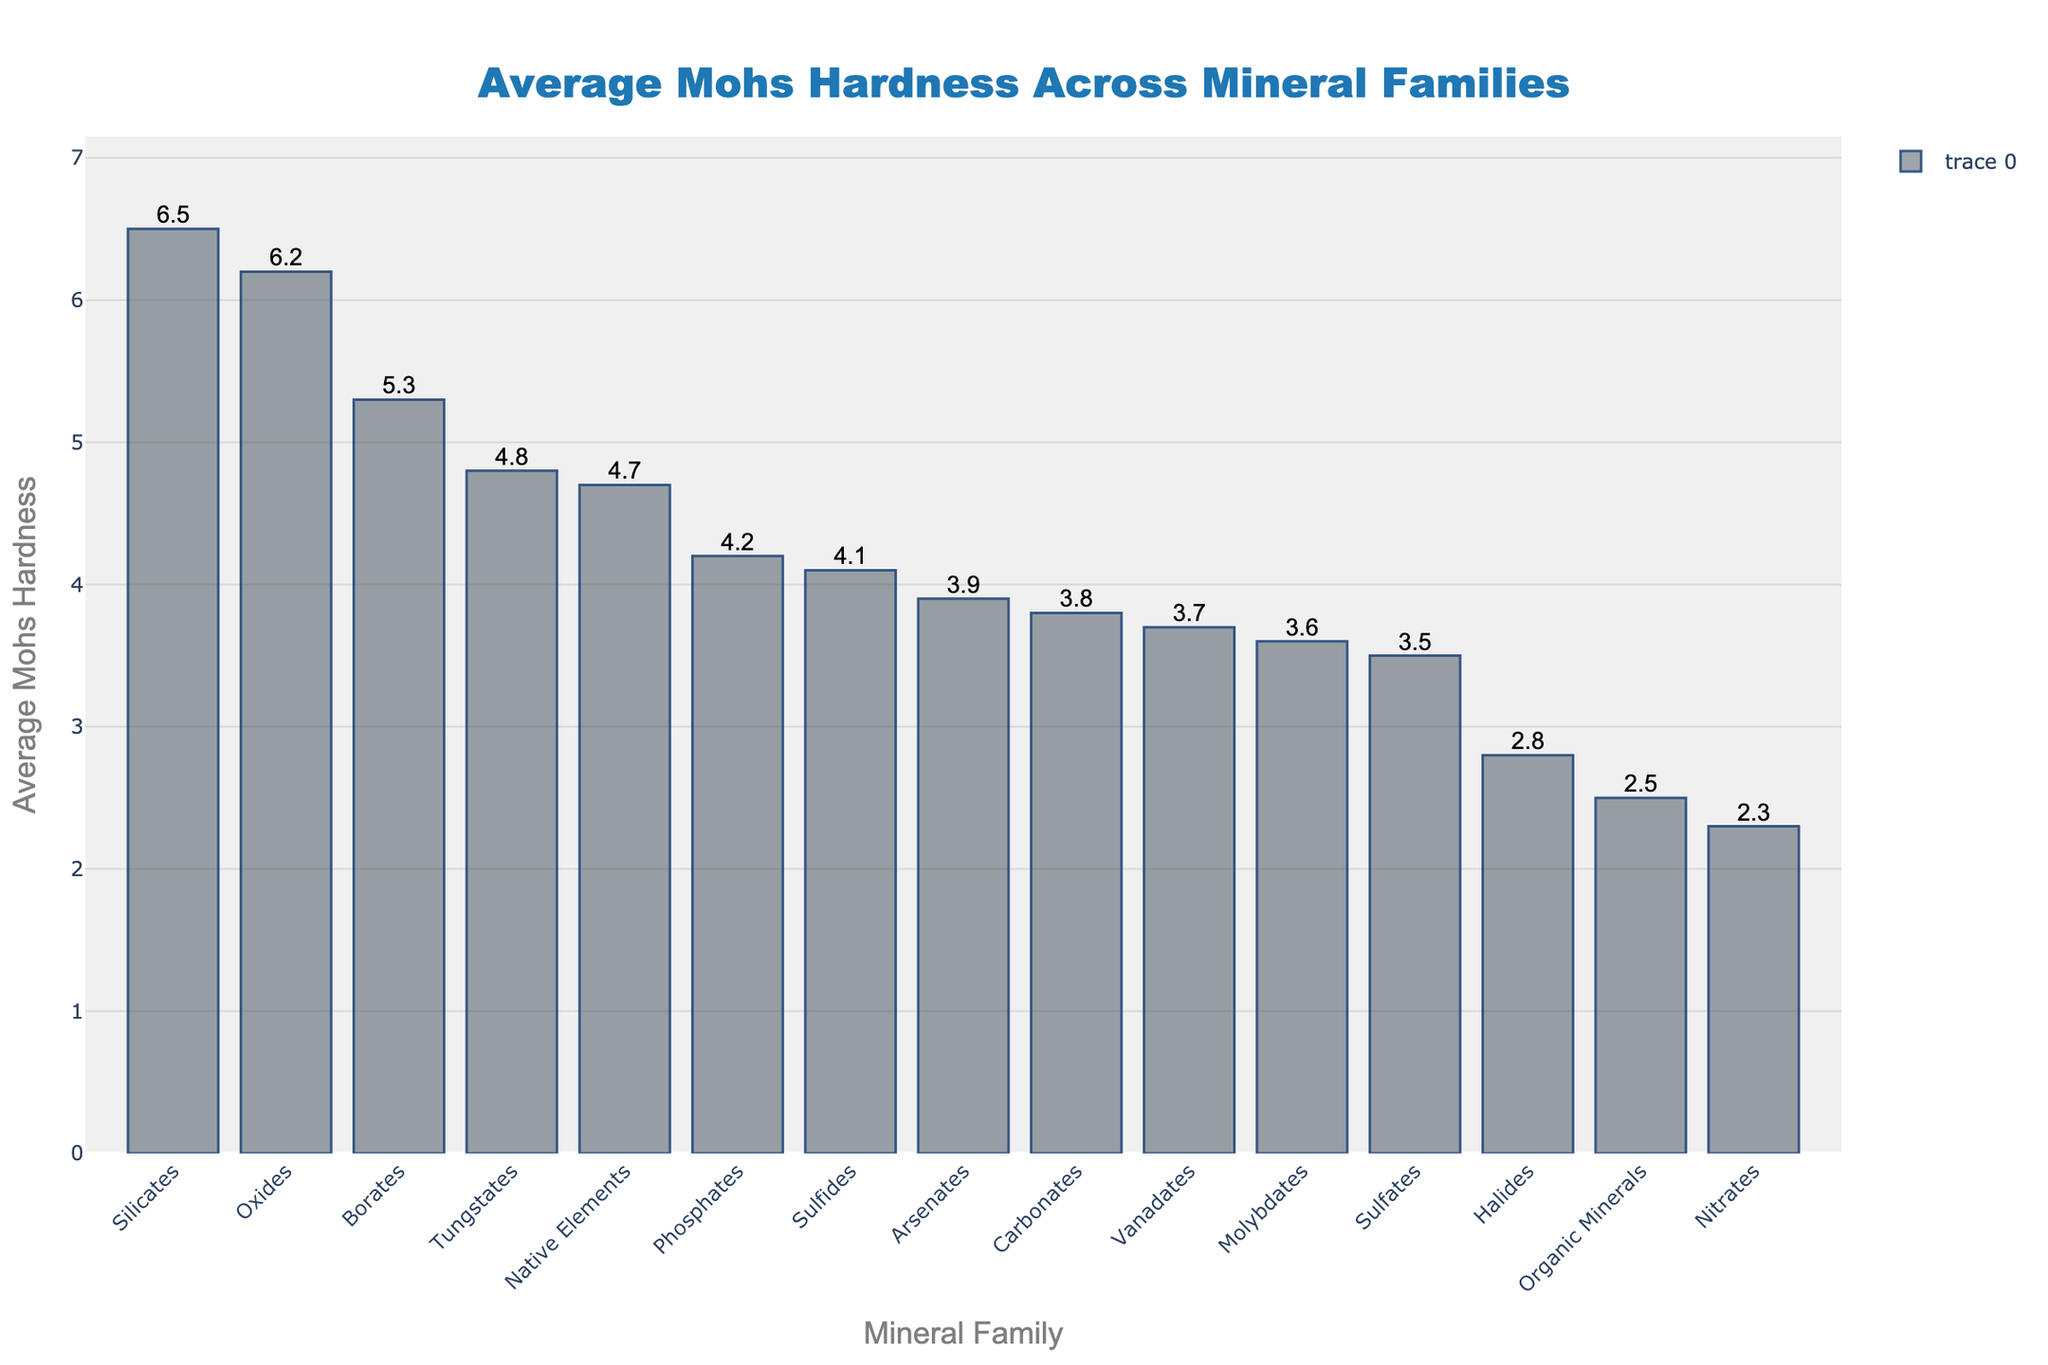Which mineral family has the highest average Mohs hardness? The bar chart shows that 'Silicates' have the highest bar, indicating the highest average Mohs hardness.
Answer: Silicates Which mineral family has a lower average Mohs hardness, Carbonates or Sulfides? Comparing the heights of the bars for Carbonates and Sulfides shows that Carbonates (3.8) have a higher average Mohs hardness than Sulfides (4.1).
Answer: Sulfides What is the average Mohs hardness of the three toughest mineral families? The three mineral families with the highest Mohs hardness are Silicates (6.5), Oxides (6.2), and Borates (5.3). Calculating their average gives (6.5 + 6.2 + 5.3) / 3 = 6.0.
Answer: 6.0 How much greater is the average Mohs hardness of Tungstates compared to Halides? Tungstates have an average Mohs hardness of 4.8 and Halides have 2.8. The difference is 4.8 - 2.8 = 2.0.
Answer: 2.0 How many mineral families have an average Mohs hardness greater than 4.0? By inspecting the bar chart and counting the bars with heights above 4.0, we find Silicates, Oxides, Borates, Tungstates, Native Elements, and Sulfides, totaling 6 mineral families.
Answer: 6 Which mineral family is closest in average Mohs hardness to Phosphates? Phosphates have an average Mohs hardness of 4.2. Comparing visually, Native Elements (4.7) and Sulfides (4.1) are close, with Sulfides being the closest.
Answer: Sulfides What is the range of average Mohs hardness across all mineral families? The hardest mineral family is Silicates at 6.5, and the softest is Nitrates at 2.3, giving a range of 6.5 - 2.3 = 4.2.
Answer: 4.2 Are there more mineral families with average Mohs hardness below or above 4.0? By examining the bar chart, we see there are 9 mineral families with an average hardness below 4.0 (Sulfates, Carbonates, etc.,), and 6 above 4.0 (Silicates, Oxides, etc.). Thus, there are more below 4.0.
Answer: Below 